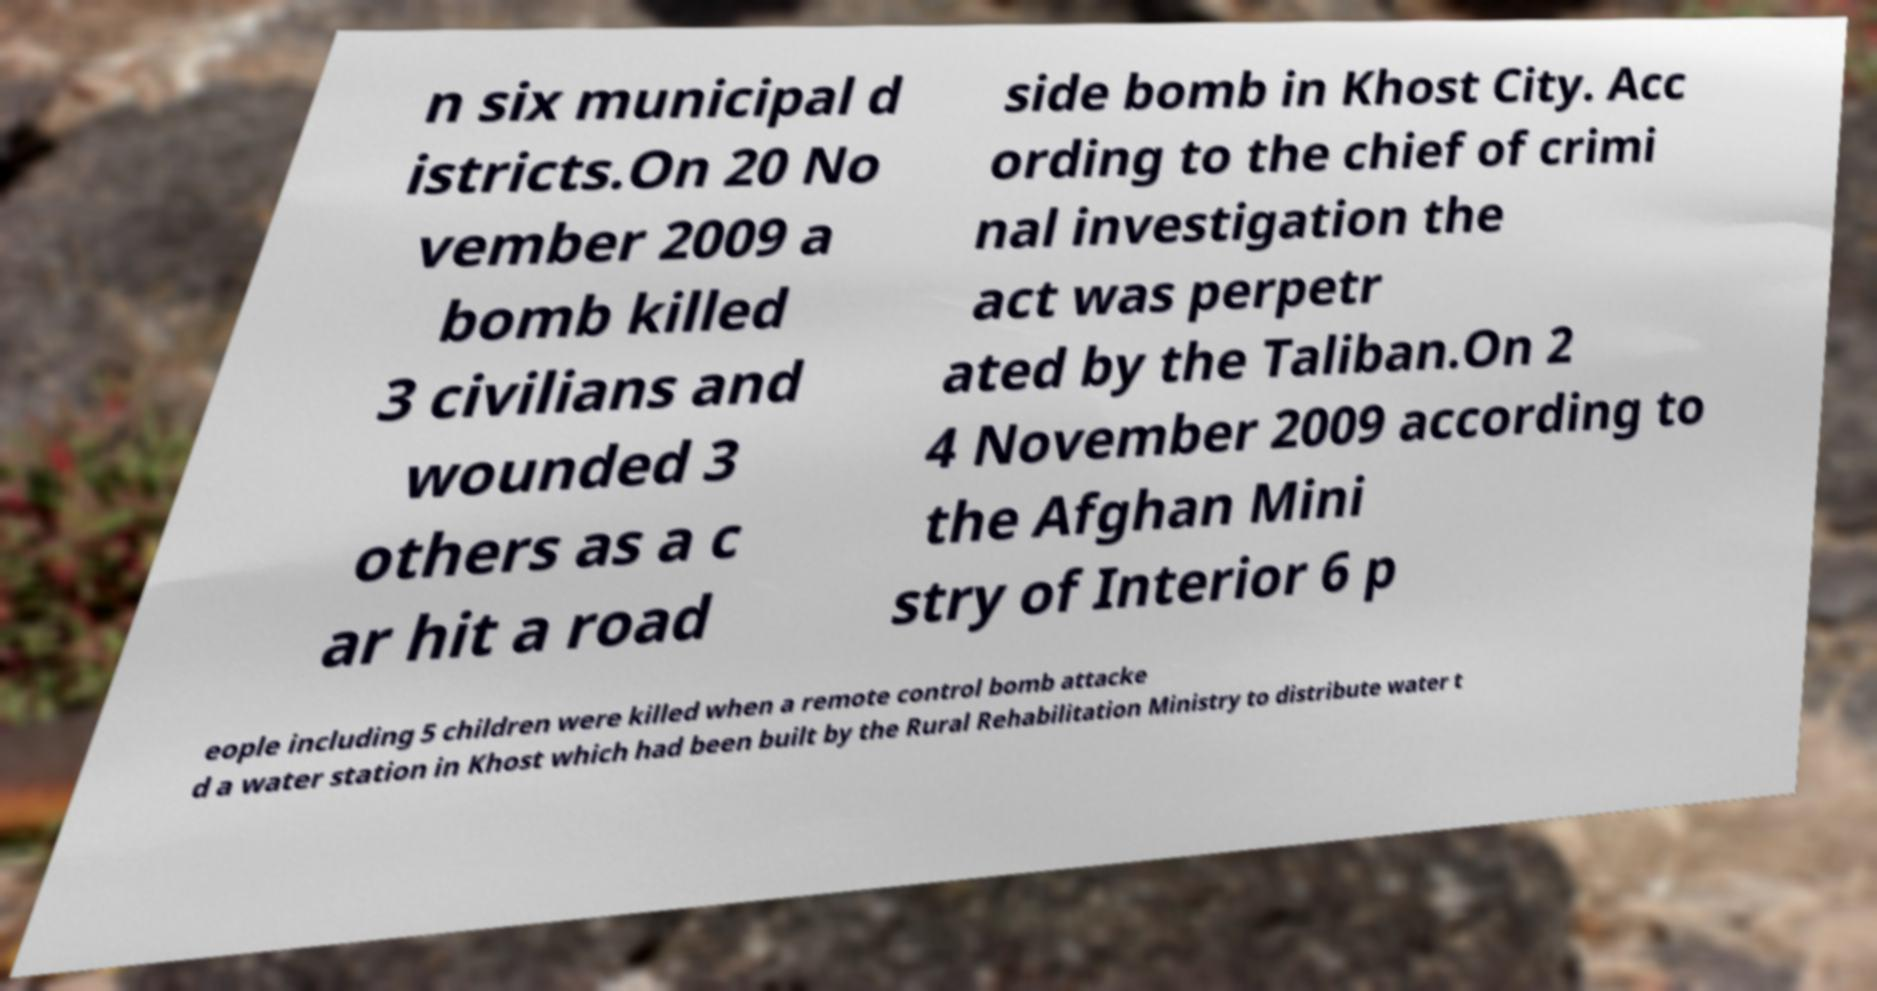There's text embedded in this image that I need extracted. Can you transcribe it verbatim? n six municipal d istricts.On 20 No vember 2009 a bomb killed 3 civilians and wounded 3 others as a c ar hit a road side bomb in Khost City. Acc ording to the chief of crimi nal investigation the act was perpetr ated by the Taliban.On 2 4 November 2009 according to the Afghan Mini stry of Interior 6 p eople including 5 children were killed when a remote control bomb attacke d a water station in Khost which had been built by the Rural Rehabilitation Ministry to distribute water t 